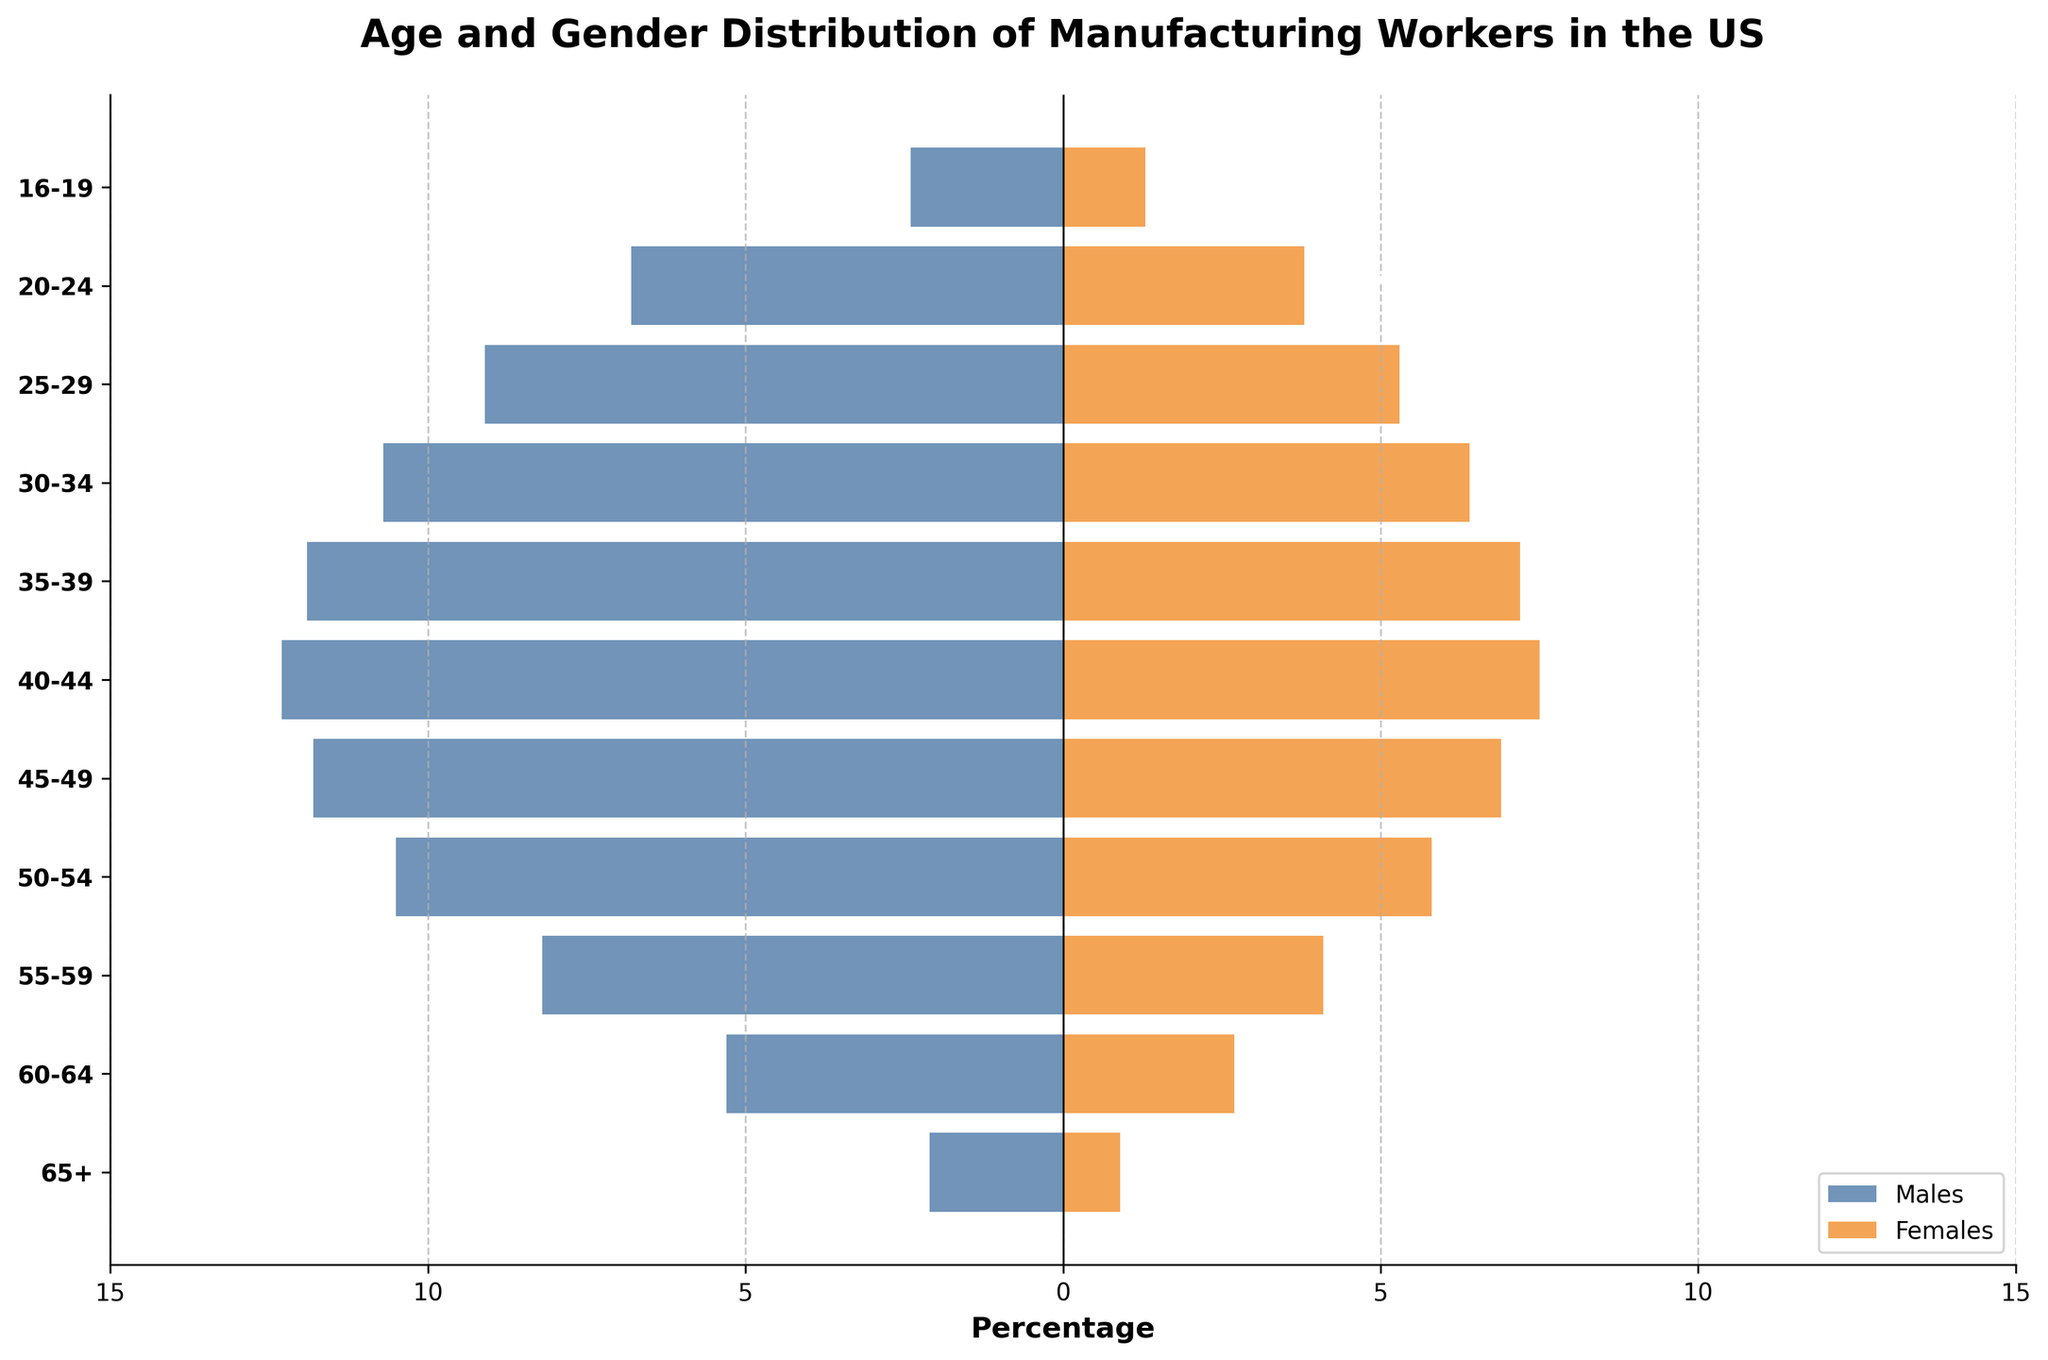What's the predominant age group for male manufacturing workers? The bars on the left side representing males show the length of each bar. The largest bar corresponds to the 40-44 age group.
Answer: 40-44 What is the total percentage of female manufacturing workers aged 55-59 and 60-64? The percentage of females aged 55-59 is 4.1% and for 60-64 is 2.7%. Summing them gives 4.1 + 2.7 = 6.8%.
Answer: 6.8% Which gender has a higher percentage in the 25-29 age group? By comparing the lengths of the bars representing males and females in the 25-29 age group, we see that the male bar is longer at 9.1% compared to 5.3% for females.
Answer: Males What percentage of male manufacturing workers is in the 16-19 age group? Looking at the first bar on the left side, which represents males in the 16-19 age group, it extends to 2.4%.
Answer: 2.4% Is there a gender gap across age groups, and how does it change with age? The bars representing males are uniformly longer than those for females across all age groups. The gap widens notably as age increases, particularly noticeable in the older age groups like 50-54 and beyond.
Answer: Yes, it widens with age Which age group has the smallest percentage of female manufacturing workers? The shortest orange bar on the right side corresponds to the 16-19 age group with 1.3%.
Answer: 16-19 What age group has the highest combined percentage for both genders? By adding the percentages for each gender within an age group and comparing totals, the 40-44 age group has the highest combined percentage with 12.3 + 7.5 = 19.8%.
Answer: 40-44 How many age groups have more than 10% of male manufacturing workers? Looking at the bars on the left side and noting those that extend beyond -10%, the age groups are 35-39, 40-44, 45-49, and 50-54, totaling four age groups.
Answer: Four Which age group has a bigger percentage difference between males and females? By calculating the percentage differences between males and females for each age group, the 65+ group has the largest difference of 2.1 - 0.9 = 1.2%.
Answer: 65+ What percentage of manufacturing workers aged 45-49 are female? Observing the length of the corresponding bar on the right side, it extends to 6.9%.
Answer: 6.9% 